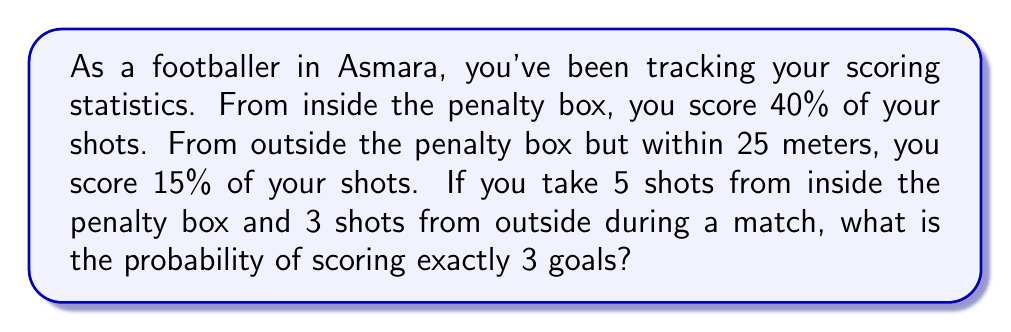Show me your answer to this math problem. Let's approach this step-by-step using the binomial probability formula and the addition rule of probability.

1) Let's define our events:
   A: Scoring from inside the penalty box (probability = 0.4)
   B: Scoring from outside the penalty box (probability = 0.15)

2) We need to find P(3 goals) = P(3A and 0B) + P(2A and 1B) + P(1A and 2B) + P(0A and 3B)

3) For each scenario, we'll use the binomial probability formula:
   $$P(X = k) = \binom{n}{k} p^k (1-p)^{n-k}$$

4) Calculating each scenario:

   P(3A and 0B) = $\binom{5}{3} (0.4)^3 (0.6)^2 \cdot \binom{3}{0} (0.15)^0 (0.85)^3$
                = $10 \cdot 0.064 \cdot 0.614125 = 0.392840$

   P(2A and 1B) = $\binom{5}{2} (0.4)^2 (0.6)^3 \cdot \binom{3}{1} (0.15)^1 (0.85)^2$
                = $10 \cdot 0.096 \cdot 3 \cdot 0.15 \cdot 0.7225 = 0.311580$

   P(1A and 2B) = $\binom{5}{1} (0.4)^1 (0.6)^4 \cdot \binom{3}{2} (0.15)^2 (0.85)^1$
                = $5 \cdot 0.0384 \cdot 3 \cdot 0.0225 \cdot 0.85 = 0.011016$

   P(0A and 3B) = $\binom{5}{0} (0.4)^0 (0.6)^5 \cdot \binom{3}{3} (0.15)^3 (0.85)^0$
                = $1 \cdot 0.07776 \cdot 1 \cdot 0.003375 = 0.000263$

5) Sum all probabilities:
   P(3 goals) = 0.392840 + 0.311580 + 0.011016 + 0.000263 = 0.715699

Therefore, the probability of scoring exactly 3 goals is approximately 0.715699 or 71.57%.
Answer: 0.715699 